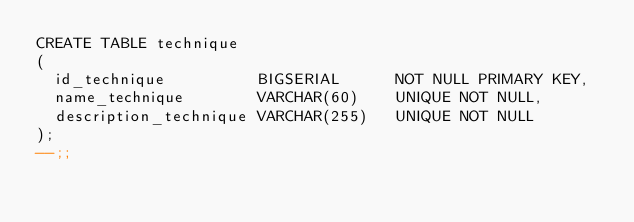Convert code to text. <code><loc_0><loc_0><loc_500><loc_500><_SQL_>CREATE TABLE technique
(
  id_technique          BIGSERIAL      NOT NULL PRIMARY KEY,
  name_technique        VARCHAR(60)    UNIQUE NOT NULL,
  description_technique VARCHAR(255)   UNIQUE NOT NULL
);
--;;</code> 